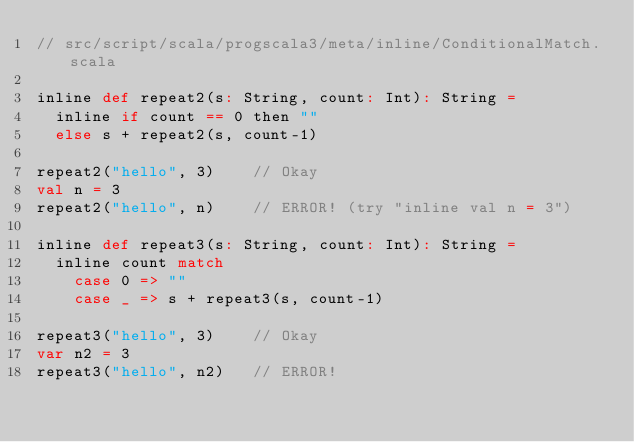<code> <loc_0><loc_0><loc_500><loc_500><_Scala_>// src/script/scala/progscala3/meta/inline/ConditionalMatch.scala

inline def repeat2(s: String, count: Int): String =
  inline if count == 0 then ""
  else s + repeat2(s, count-1)

repeat2("hello", 3)    // Okay
val n = 3
repeat2("hello", n)    // ERROR! (try "inline val n = 3")

inline def repeat3(s: String, count: Int): String =
  inline count match
    case 0 => ""
    case _ => s + repeat3(s, count-1)

repeat3("hello", 3)    // Okay
var n2 = 3
repeat3("hello", n2)   // ERROR!
</code> 